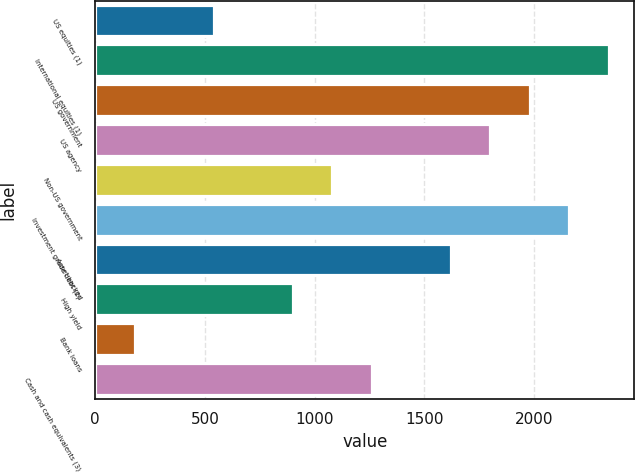Convert chart. <chart><loc_0><loc_0><loc_500><loc_500><bar_chart><fcel>US equities (1)<fcel>International equities (1)<fcel>US government<fcel>US agency<fcel>Non-US government<fcel>Investment grade debt (2)<fcel>Asset backed<fcel>High yield<fcel>Bank loans<fcel>Cash and cash equivalents (3)<nl><fcel>541.21<fcel>2342.31<fcel>1982.09<fcel>1801.98<fcel>1081.54<fcel>2162.2<fcel>1621.87<fcel>901.43<fcel>180.99<fcel>1261.65<nl></chart> 